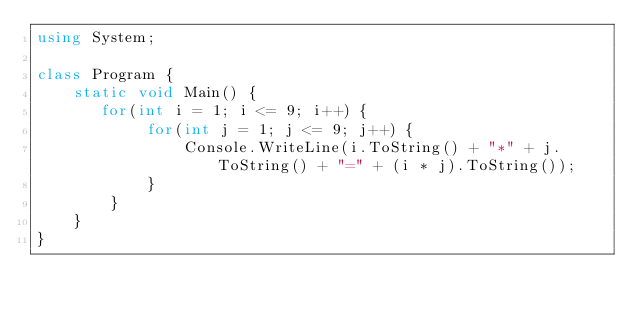Convert code to text. <code><loc_0><loc_0><loc_500><loc_500><_C#_>using System;

class Program {
    static void Main() {
       for(int i = 1; i <= 9; i++) {
            for(int j = 1; j <= 9; j++) {
                Console.WriteLine(i.ToString() + "*" + j.ToString() + "=" + (i * j).ToString());
            }
        }
    }
}</code> 